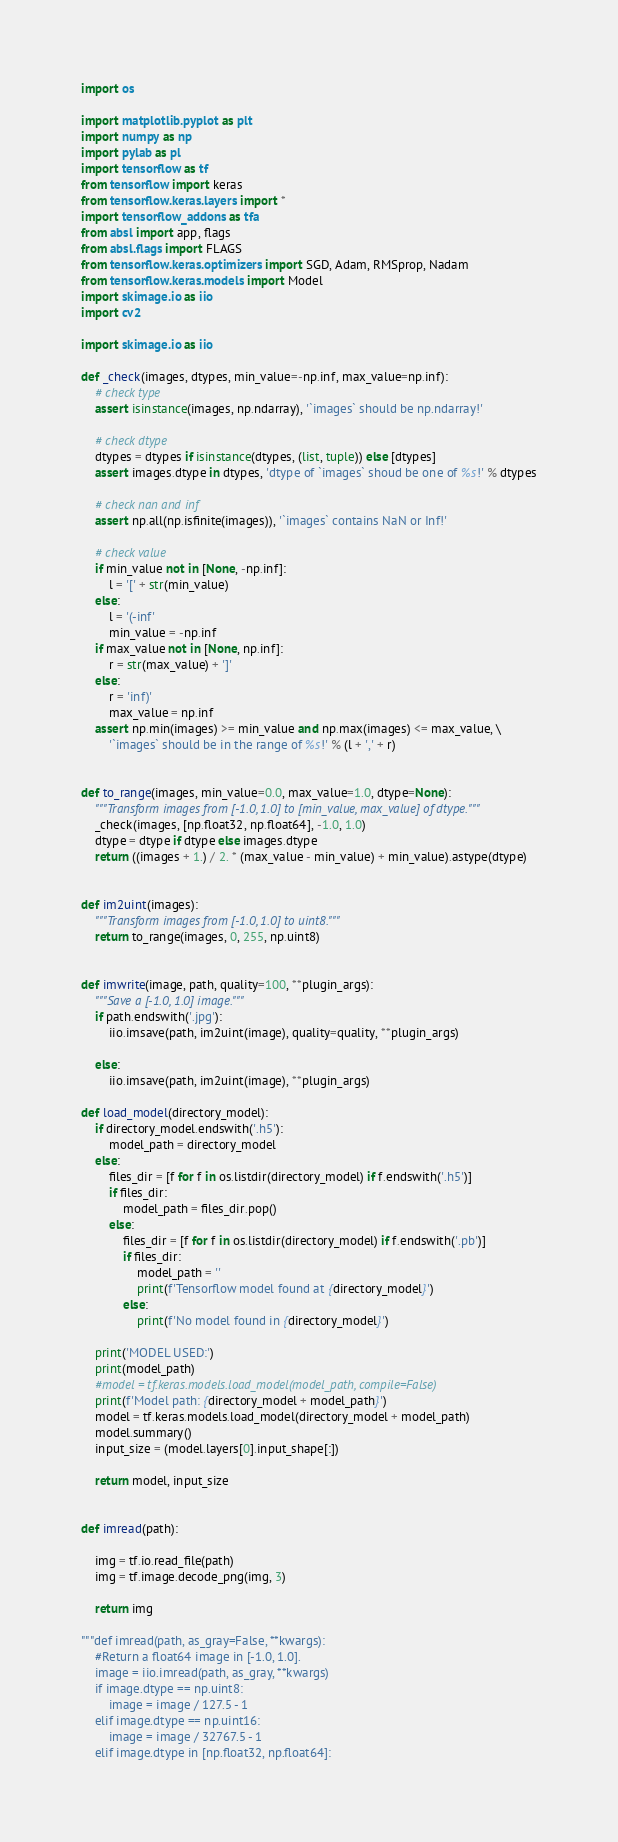<code> <loc_0><loc_0><loc_500><loc_500><_Python_>import os

import matplotlib.pyplot as plt
import numpy as np
import pylab as pl
import tensorflow as tf
from tensorflow import keras
from tensorflow.keras.layers import *
import tensorflow_addons as tfa
from absl import app, flags
from absl.flags import FLAGS
from tensorflow.keras.optimizers import SGD, Adam, RMSprop, Nadam
from tensorflow.keras.models import Model
import skimage.io as iio
import cv2

import skimage.io as iio

def _check(images, dtypes, min_value=-np.inf, max_value=np.inf):
    # check type
    assert isinstance(images, np.ndarray), '`images` should be np.ndarray!'

    # check dtype
    dtypes = dtypes if isinstance(dtypes, (list, tuple)) else [dtypes]
    assert images.dtype in dtypes, 'dtype of `images` shoud be one of %s!' % dtypes

    # check nan and inf
    assert np.all(np.isfinite(images)), '`images` contains NaN or Inf!'

    # check value
    if min_value not in [None, -np.inf]:
        l = '[' + str(min_value)
    else:
        l = '(-inf'
        min_value = -np.inf
    if max_value not in [None, np.inf]:
        r = str(max_value) + ']'
    else:
        r = 'inf)'
        max_value = np.inf
    assert np.min(images) >= min_value and np.max(images) <= max_value, \
        '`images` should be in the range of %s!' % (l + ',' + r)


def to_range(images, min_value=0.0, max_value=1.0, dtype=None):
    """Transform images from [-1.0, 1.0] to [min_value, max_value] of dtype."""
    _check(images, [np.float32, np.float64], -1.0, 1.0)
    dtype = dtype if dtype else images.dtype
    return ((images + 1.) / 2. * (max_value - min_value) + min_value).astype(dtype)


def im2uint(images):
    """Transform images from [-1.0, 1.0] to uint8."""
    return to_range(images, 0, 255, np.uint8)


def imwrite(image, path, quality=100, **plugin_args):
    """Save a [-1.0, 1.0] image."""
    if path.endswith('.jpg'):
        iio.imsave(path, im2uint(image), quality=quality, **plugin_args)

    else:
        iio.imsave(path, im2uint(image), **plugin_args)

def load_model(directory_model):
    if directory_model.endswith('.h5'):
        model_path = directory_model
    else:
        files_dir = [f for f in os.listdir(directory_model) if f.endswith('.h5')]
        if files_dir:
            model_path = files_dir.pop()
        else:
            files_dir = [f for f in os.listdir(directory_model) if f.endswith('.pb')]
            if files_dir:
                model_path = ''
                print(f'Tensorflow model found at {directory_model}')
            else:
                print(f'No model found in {directory_model}')

    print('MODEL USED:')
    print(model_path)
    #model = tf.keras.models.load_model(model_path, compile=False)
    print(f'Model path: {directory_model + model_path}')
    model = tf.keras.models.load_model(directory_model + model_path)
    model.summary()
    input_size = (model.layers[0].input_shape[:])

    return model, input_size


def imread(path):

    img = tf.io.read_file(path)
    img = tf.image.decode_png(img, 3)

    return img

"""def imread(path, as_gray=False, **kwargs):
    #Return a float64 image in [-1.0, 1.0].
    image = iio.imread(path, as_gray, **kwargs)
    if image.dtype == np.uint8:
        image = image / 127.5 - 1
    elif image.dtype == np.uint16:
        image = image / 32767.5 - 1
    elif image.dtype in [np.float32, np.float64]:</code> 